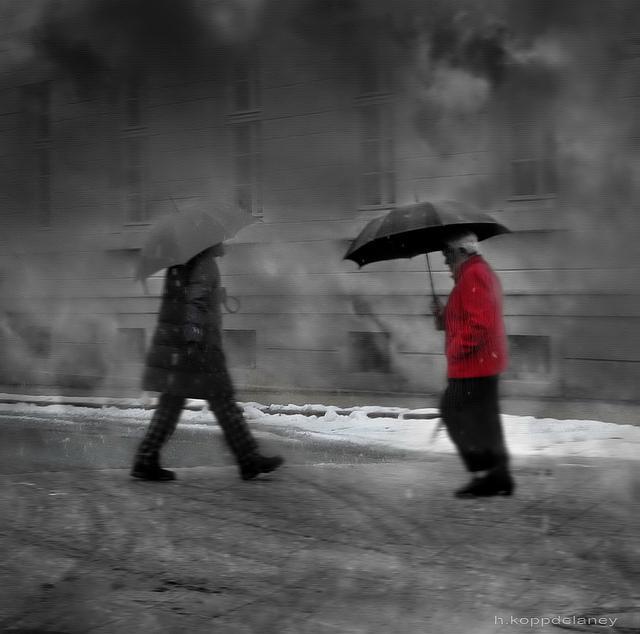How many people are here?
Give a very brief answer. 2. How many umbrellas are in the photo?
Give a very brief answer. 2. How many people are there?
Give a very brief answer. 2. 